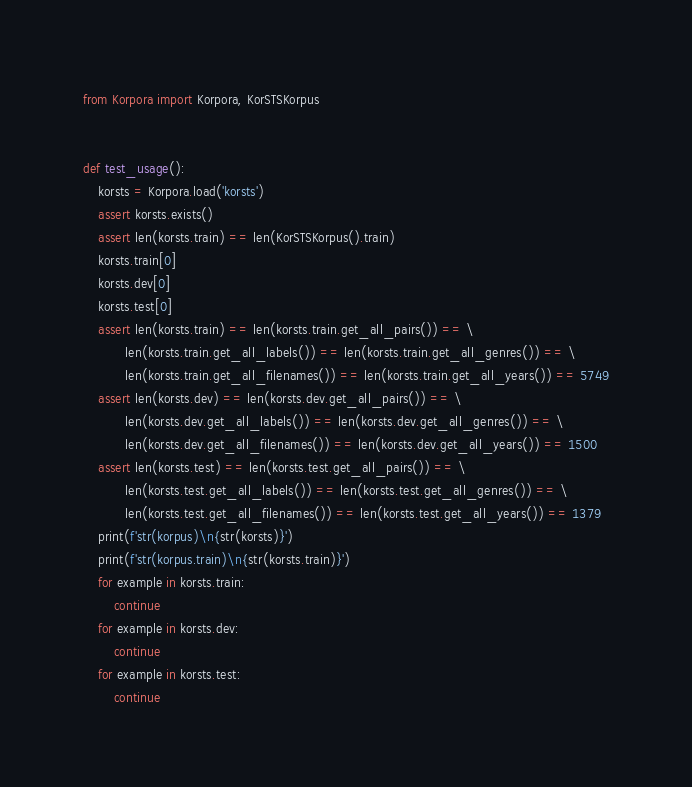Convert code to text. <code><loc_0><loc_0><loc_500><loc_500><_Python_>from Korpora import Korpora, KorSTSKorpus


def test_usage():
    korsts = Korpora.load('korsts')
    assert korsts.exists()
    assert len(korsts.train) == len(KorSTSKorpus().train)
    korsts.train[0]
    korsts.dev[0]
    korsts.test[0]
    assert len(korsts.train) == len(korsts.train.get_all_pairs()) == \
           len(korsts.train.get_all_labels()) == len(korsts.train.get_all_genres()) == \
           len(korsts.train.get_all_filenames()) == len(korsts.train.get_all_years()) == 5749
    assert len(korsts.dev) == len(korsts.dev.get_all_pairs()) == \
           len(korsts.dev.get_all_labels()) == len(korsts.dev.get_all_genres()) == \
           len(korsts.dev.get_all_filenames()) == len(korsts.dev.get_all_years()) == 1500
    assert len(korsts.test) == len(korsts.test.get_all_pairs()) == \
           len(korsts.test.get_all_labels()) == len(korsts.test.get_all_genres()) == \
           len(korsts.test.get_all_filenames()) == len(korsts.test.get_all_years()) == 1379
    print(f'str(korpus)\n{str(korsts)}')
    print(f'str(korpus.train)\n{str(korsts.train)}')
    for example in korsts.train:
        continue
    for example in korsts.dev:
        continue
    for example in korsts.test:
        continue
</code> 